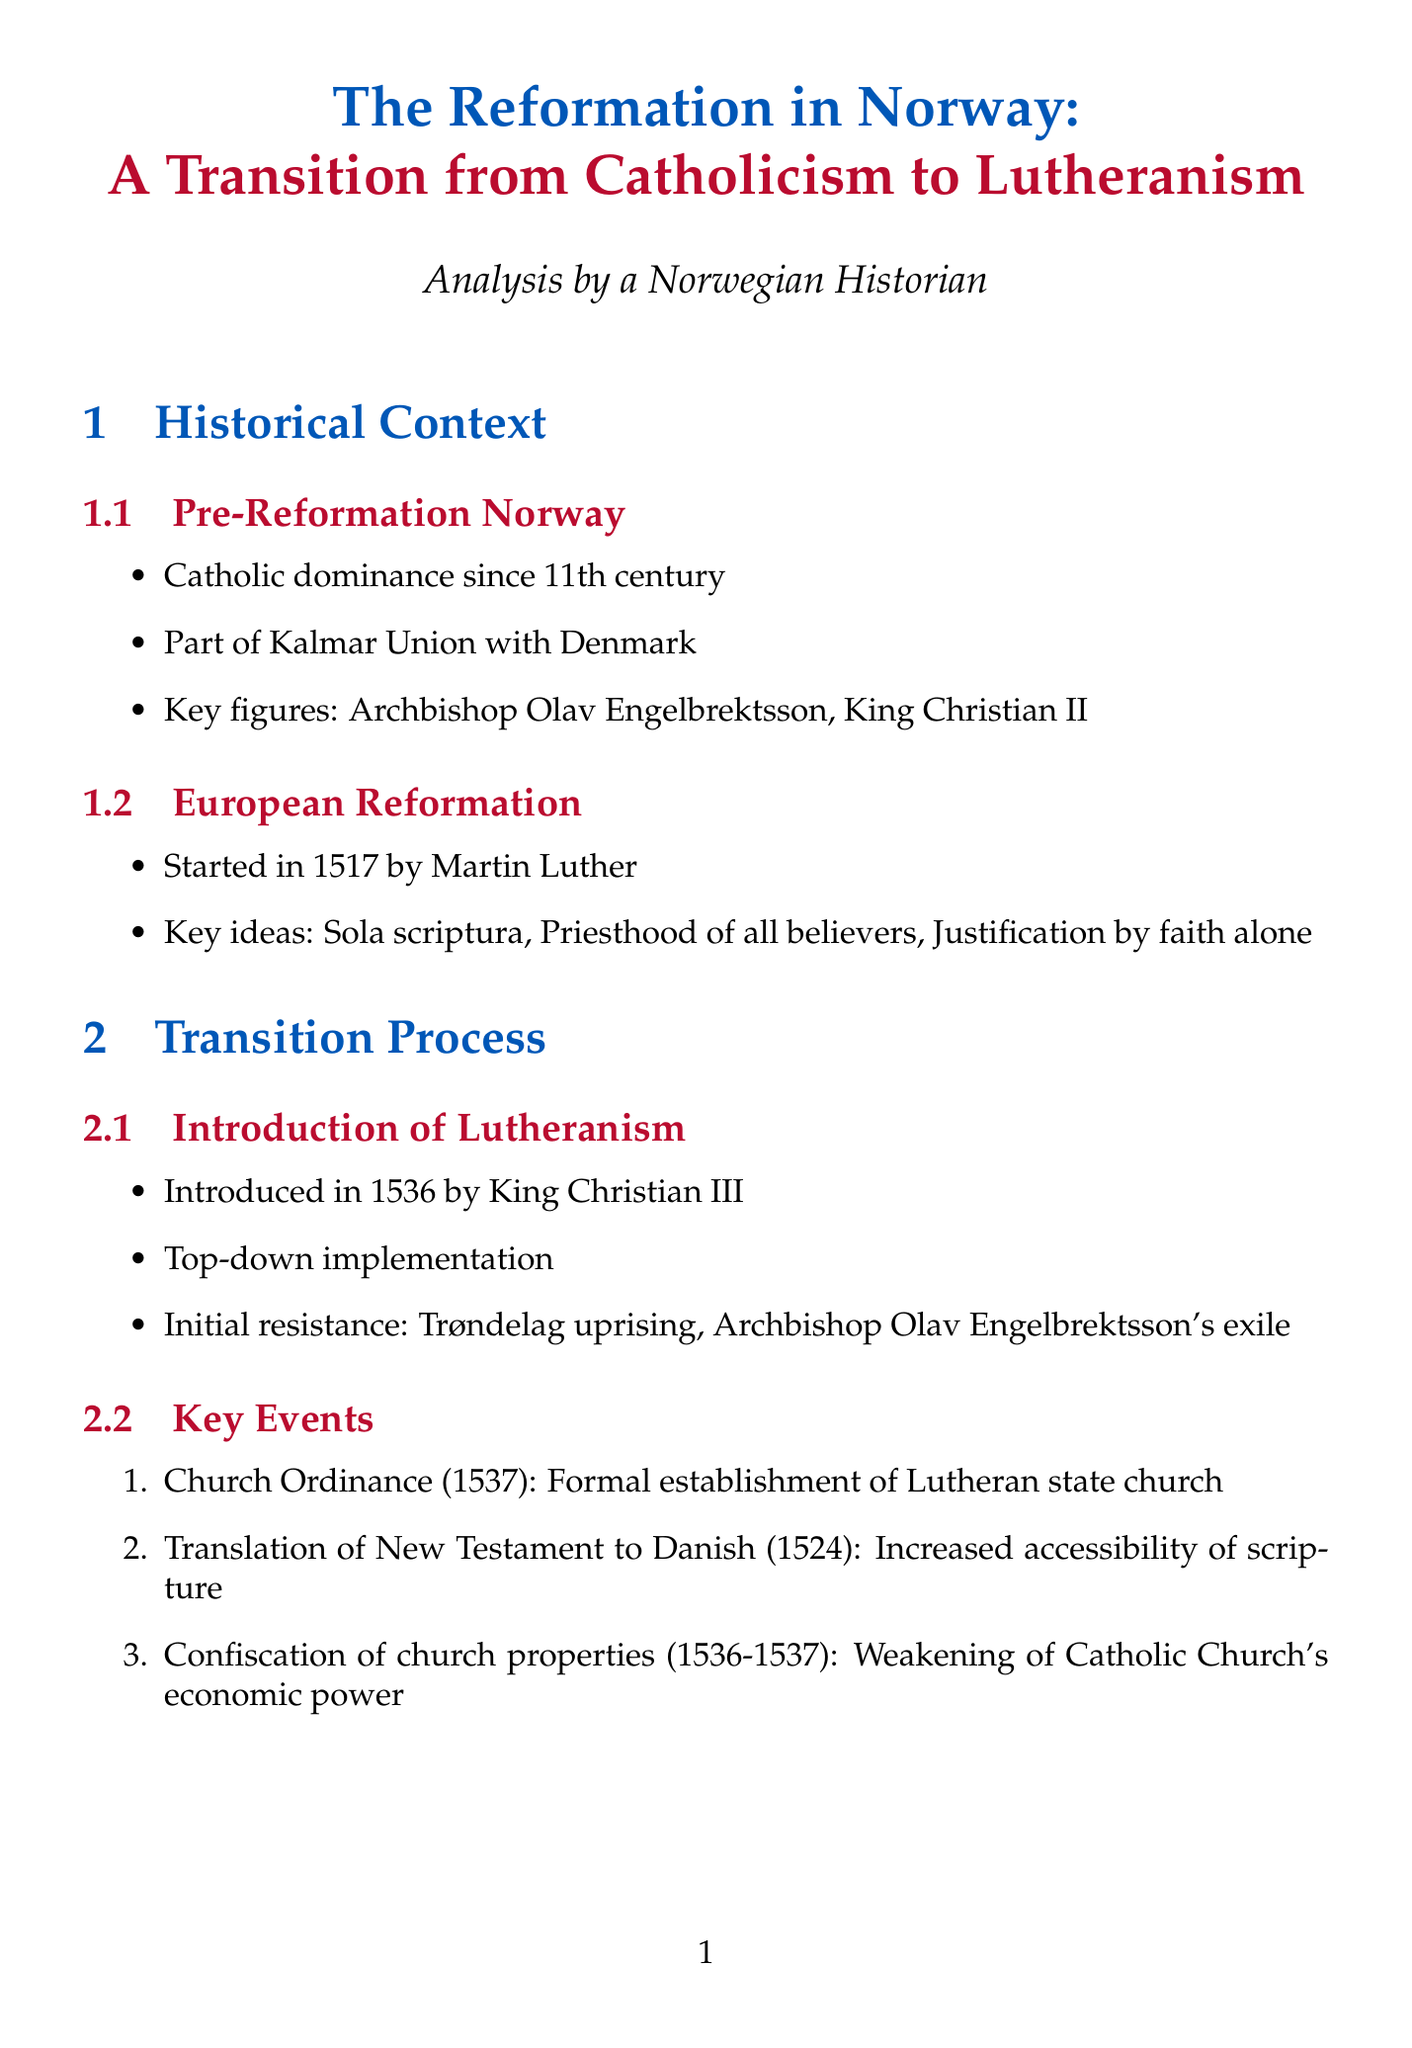What was the key figure who introduced Lutheranism to Norway? The document states that King Christian III was the key figure responsible for introducing Lutheranism in Norway.
Answer: King Christian III What year did the Church Ordinance establish the Lutheran state church? According to the document, the Church Ordinance was enacted in 1537, formalizing the establishment of the Lutheran state church.
Answer: 1537 What was the primary method of implementing Lutheranism in Norway? The document indicates that Lutheranism was implemented through a top-down approach, led by the monarchy.
Answer: Top-down implementation What significant event happened in 1524 in Norway related to the Reformation? The translation of the New Testament to Danish occurred in 1524, increasing the accessibility of scripture for the populace.
Answer: Translation of New Testament to Danish What was the impact of the transition on the church's economic power? The confiscation of church properties from 1536 to 1537 weakened the economic power of the Catholic Church in Norway.
Answer: Weakening of Catholic Church's economic power Which region in Norway is characterized by a slower transition to Lutheranism? The document specifies Telemark as an example of a rural area that experienced a slower transition and persistence of Catholic practices.
Answer: Telemark What was a major change in social welfare resulting from the Reformation? The Reformation led to a shift from monastic to state-run poor relief, restructuring the former social support systems.
Answer: Shift from monastic to state-run poor relief How did Lutheranism influence the educational landscape in Norway? The establishment of Lutheran schools significantly increased literacy rates and biblical knowledge among the populace.
Answer: Increased literacy rates and biblical knowledge Which union was Norway a part of before the Reformation? The document mentions that prior to the Reformation, Norway was part of the Kalmar Union with Denmark.
Answer: Kalmar Union 